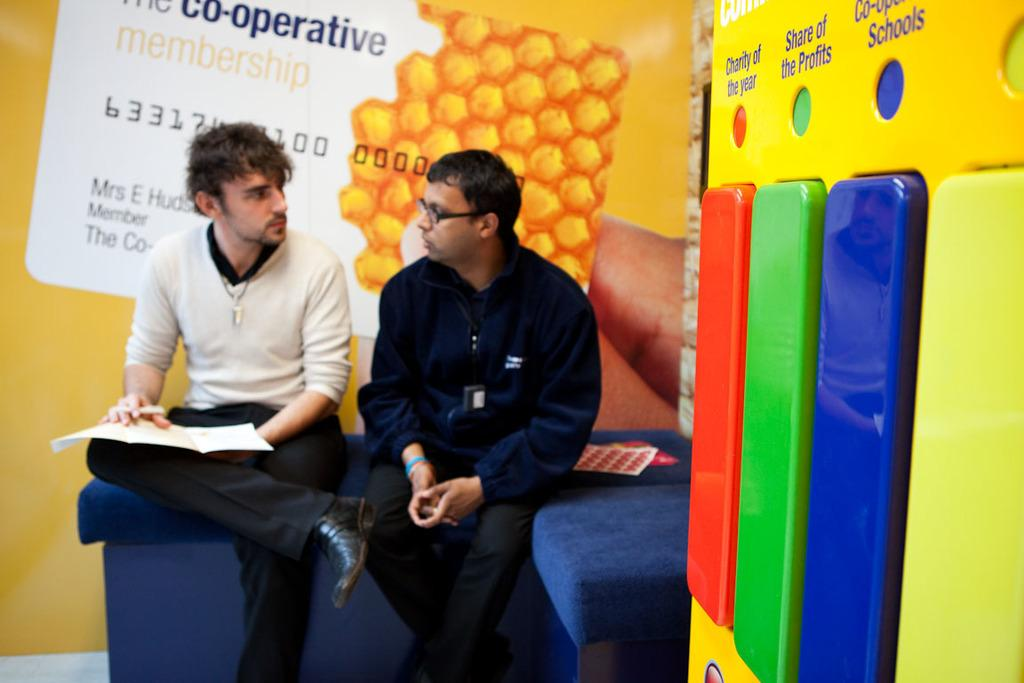How many people are in the image? There are two men in the image. What are the men doing in the image? The men are sitting on a sofa. Can you describe one of the men's appearance? One of the men is wearing spectacles. What can be seen in the background of the image? There is a wall in the background of the image. What type of hill can be seen behind the men in the image? There is no hill visible in the image; it only shows two men sitting on a sofa and a wall in the background. 